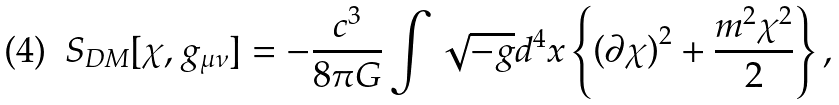Convert formula to latex. <formula><loc_0><loc_0><loc_500><loc_500>S _ { D M } [ \chi , g _ { \mu \nu } ] = - \frac { c ^ { 3 } } { 8 \pi G } \int \sqrt { - g } d ^ { 4 } x \left \{ \left ( \partial \chi \right ) ^ { 2 } + \frac { m ^ { 2 } \chi ^ { 2 } } { 2 } \right \} ,</formula> 